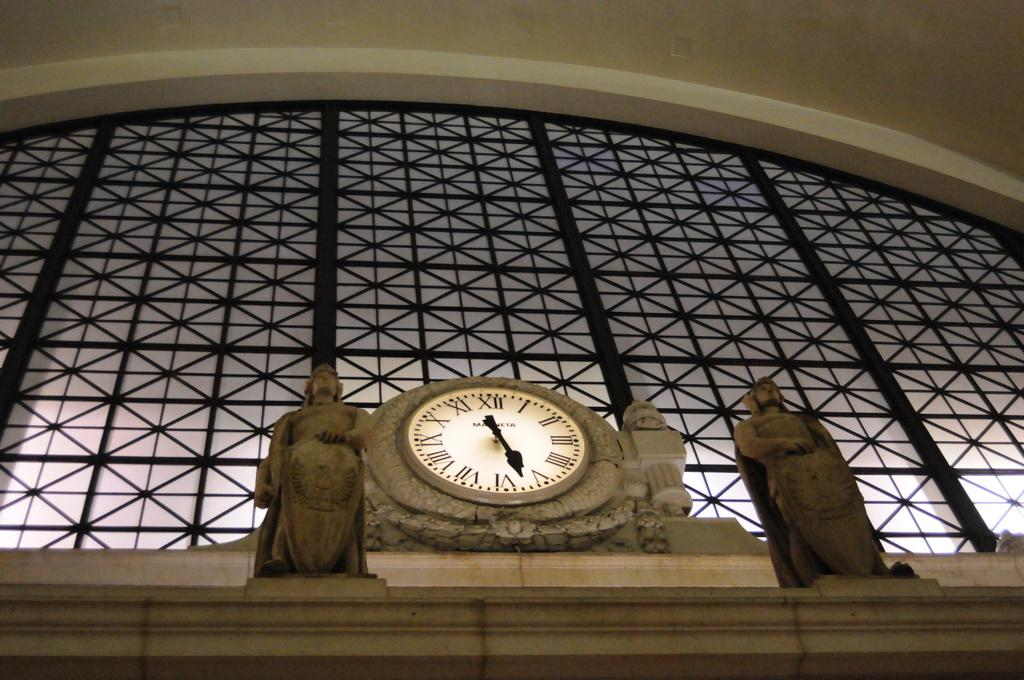What type of structure is present in the image? There is a building in the image. What is attached to the building? A clock is attached to the building. What type of artistic objects can be seen in the image? There are sculptures in the image. What type of society is depicted in the image? There is no depiction of a society in the image; it features a building with a clock and sculptures. Can you tell me how many farmers are present in the image? There are no farmers present in the image. What type of kiss can be seen between the two figures in the image? There are no figures or kisses present in the image. 